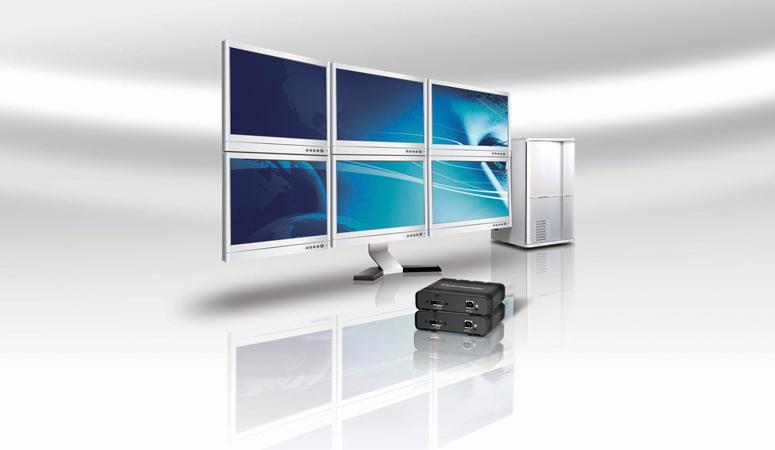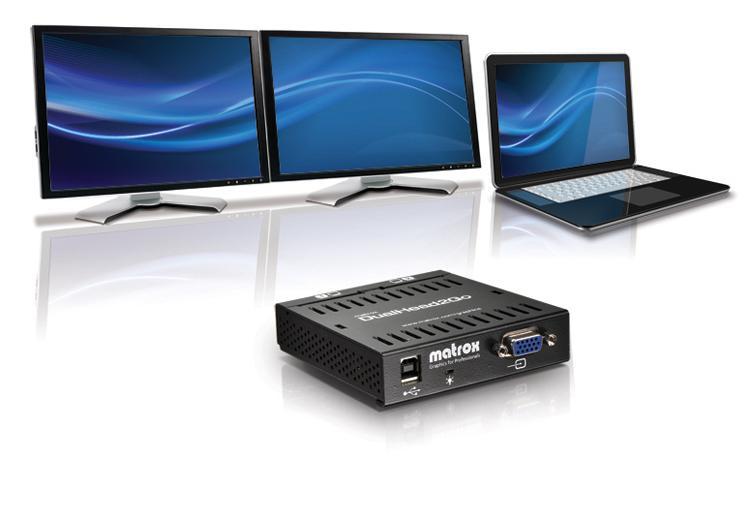The first image is the image on the left, the second image is the image on the right. Given the left and right images, does the statement "An image includes side-by-side monitors with blue curving lines on the screen, and a smaller laptop." hold true? Answer yes or no. Yes. The first image is the image on the left, the second image is the image on the right. Considering the images on both sides, is "There is exactly one laptop in the left image." valid? Answer yes or no. No. 